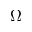Convert formula to latex. <formula><loc_0><loc_0><loc_500><loc_500>\Omega</formula> 